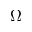Convert formula to latex. <formula><loc_0><loc_0><loc_500><loc_500>\Omega</formula> 